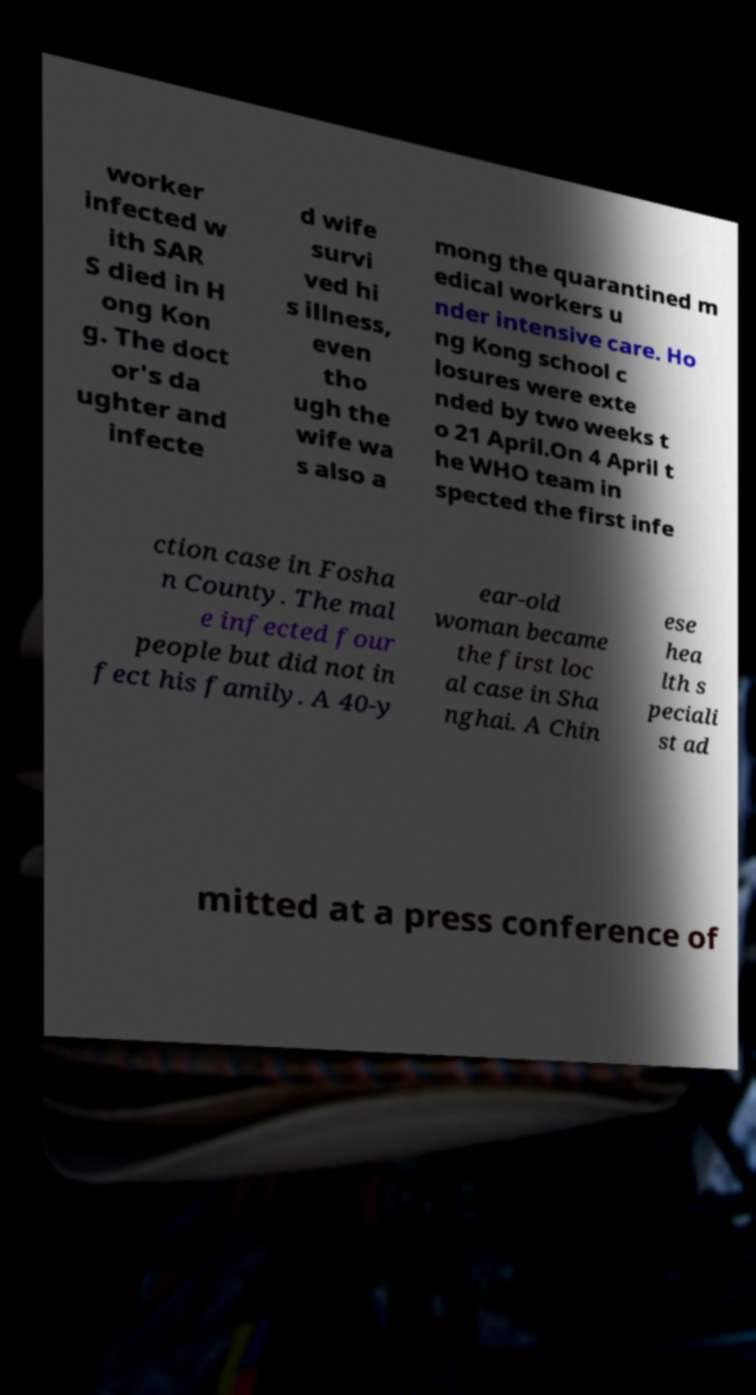What messages or text are displayed in this image? I need them in a readable, typed format. worker infected w ith SAR S died in H ong Kon g. The doct or's da ughter and infecte d wife survi ved hi s illness, even tho ugh the wife wa s also a mong the quarantined m edical workers u nder intensive care. Ho ng Kong school c losures were exte nded by two weeks t o 21 April.On 4 April t he WHO team in spected the first infe ction case in Fosha n County. The mal e infected four people but did not in fect his family. A 40-y ear-old woman became the first loc al case in Sha nghai. A Chin ese hea lth s peciali st ad mitted at a press conference of 